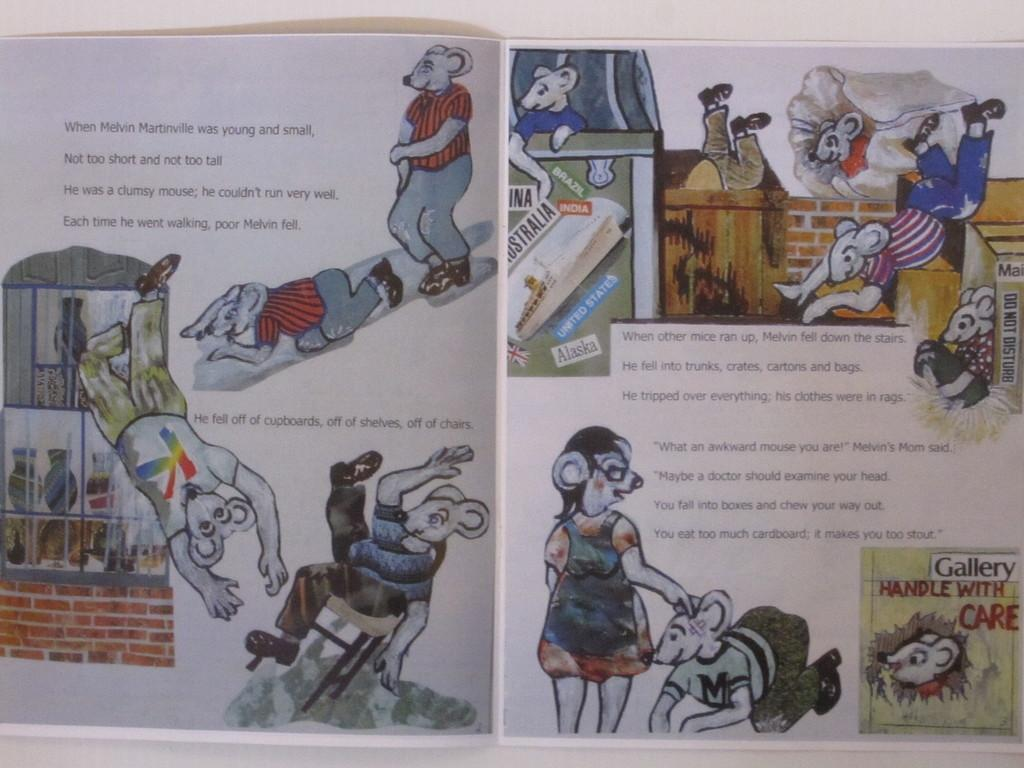<image>
Provide a brief description of the given image. A book about a mouse named Melvin Martinville is opened. 